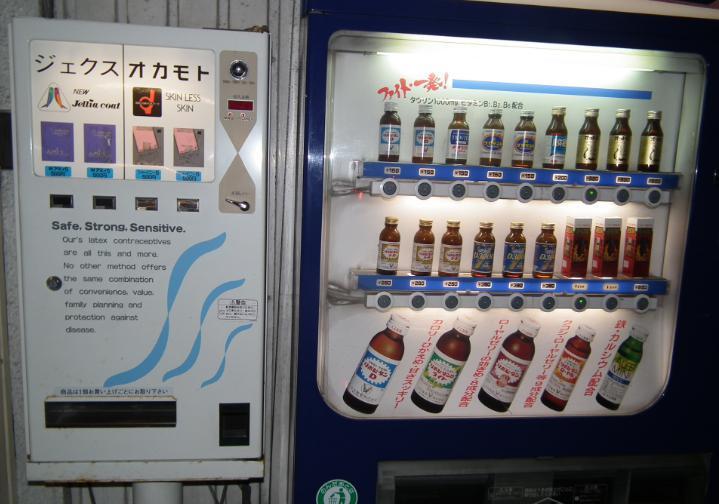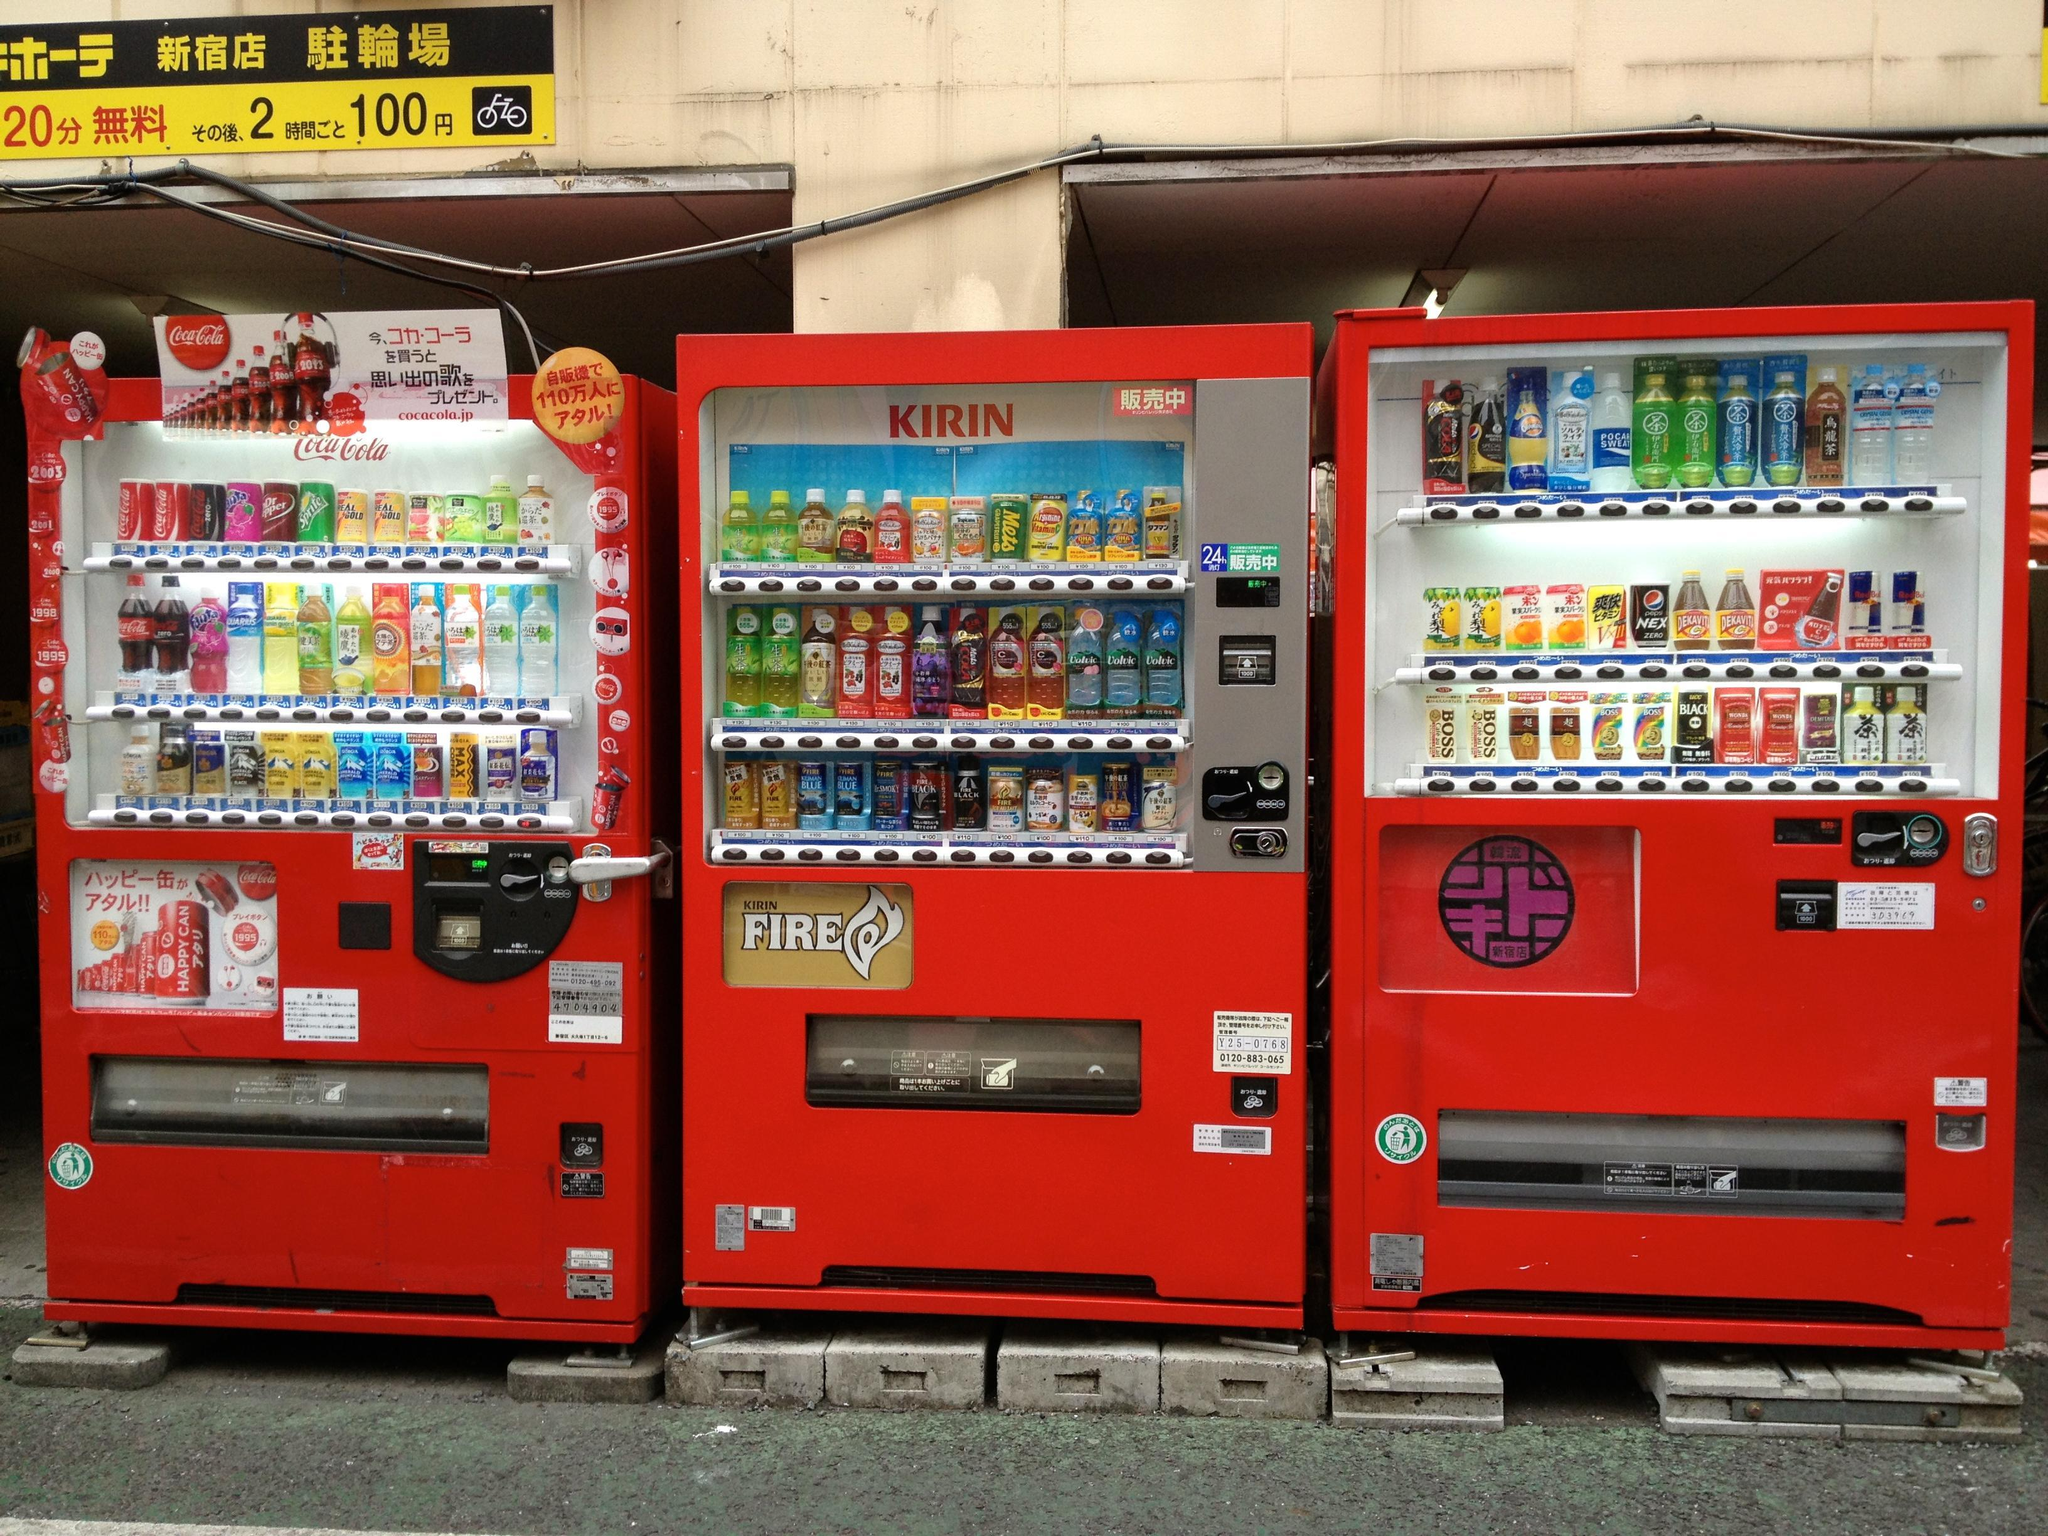The first image is the image on the left, the second image is the image on the right. Considering the images on both sides, is "There are three beverage vending machines in one of the images." valid? Answer yes or no. Yes. The first image is the image on the left, the second image is the image on the right. Considering the images on both sides, is "A trio of vending machines includes at least one red one." valid? Answer yes or no. Yes. The first image is the image on the left, the second image is the image on the right. Examine the images to the left and right. Is the description "A bank of exactly three vending machines appears in one image." accurate? Answer yes or no. Yes. The first image is the image on the left, the second image is the image on the right. Evaluate the accuracy of this statement regarding the images: "An image shows a row of exactly three vending machines.". Is it true? Answer yes or no. Yes. 